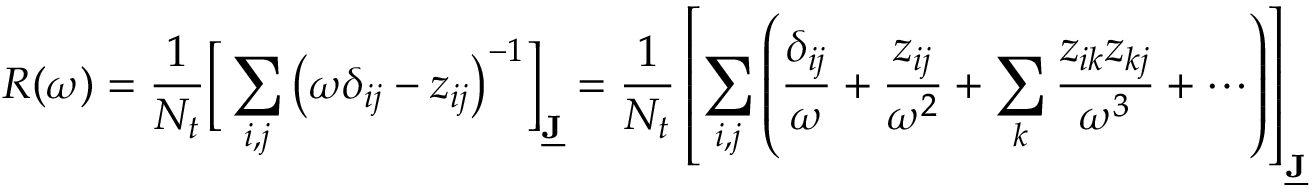<formula> <loc_0><loc_0><loc_500><loc_500>R ( \omega ) = \frac { 1 } { N _ { t } } \left [ \sum _ { i , j } \left ( \omega \delta _ { i j } - z _ { i j } \right ) ^ { - 1 } \right ] _ { \underline { J } } = \frac { 1 } { N _ { t } } \left [ \sum _ { i , j } \left ( \frac { \delta _ { i j } } { \omega } + \frac { z _ { i j } } { \omega ^ { 2 } } + \sum _ { k } \frac { z _ { i k } z _ { k j } } { \omega ^ { 3 } } + \cdots \right ) \right ] _ { \underline { J } }</formula> 